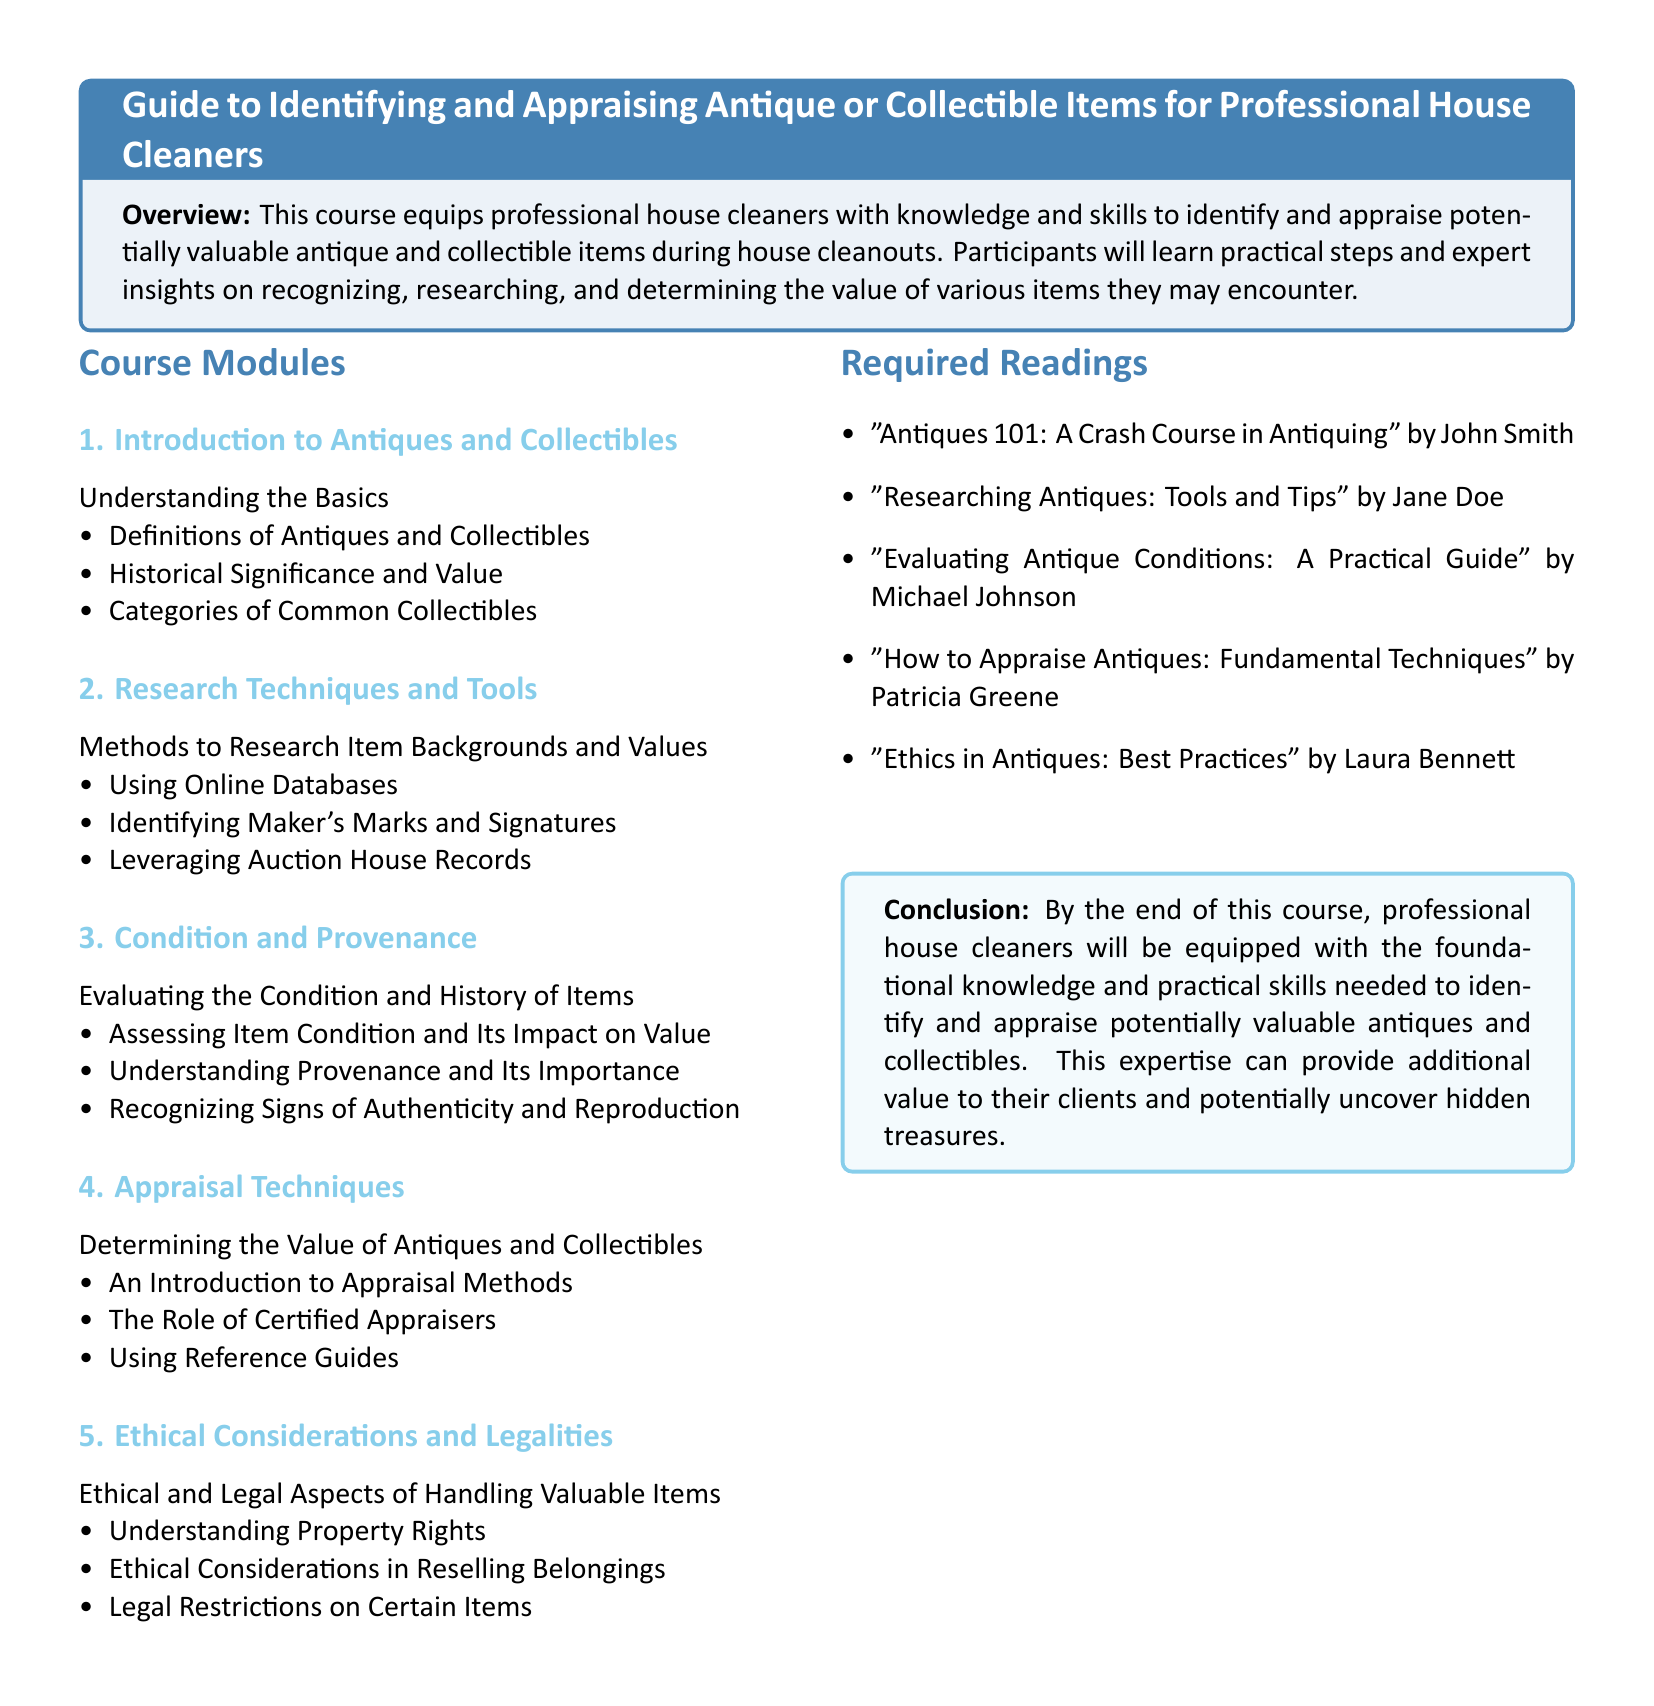What is the title of the course? The title of the course is found at the beginning of the document in the tcolorbox section.
Answer: Guide to Identifying and Appraising Antique or Collectible Items for Professional House Cleaners How many modules are listed in the course? The number of modules can be determined by counting the subsections in the Course Modules section.
Answer: 5 Who is the author of "Antiques 101: A Crash Course in Antiquing"? The author's name is located in the Required Readings section.
Answer: John Smith What is the focus of Module 3? The topic of Module 3 is indicated in the Course Modules section as well.
Answer: Condition and Provenance What should professional house cleaners understand regarding property rights? This aspect is discussed in the Ethical Considerations and Legalities module.
Answer: Property Rights 